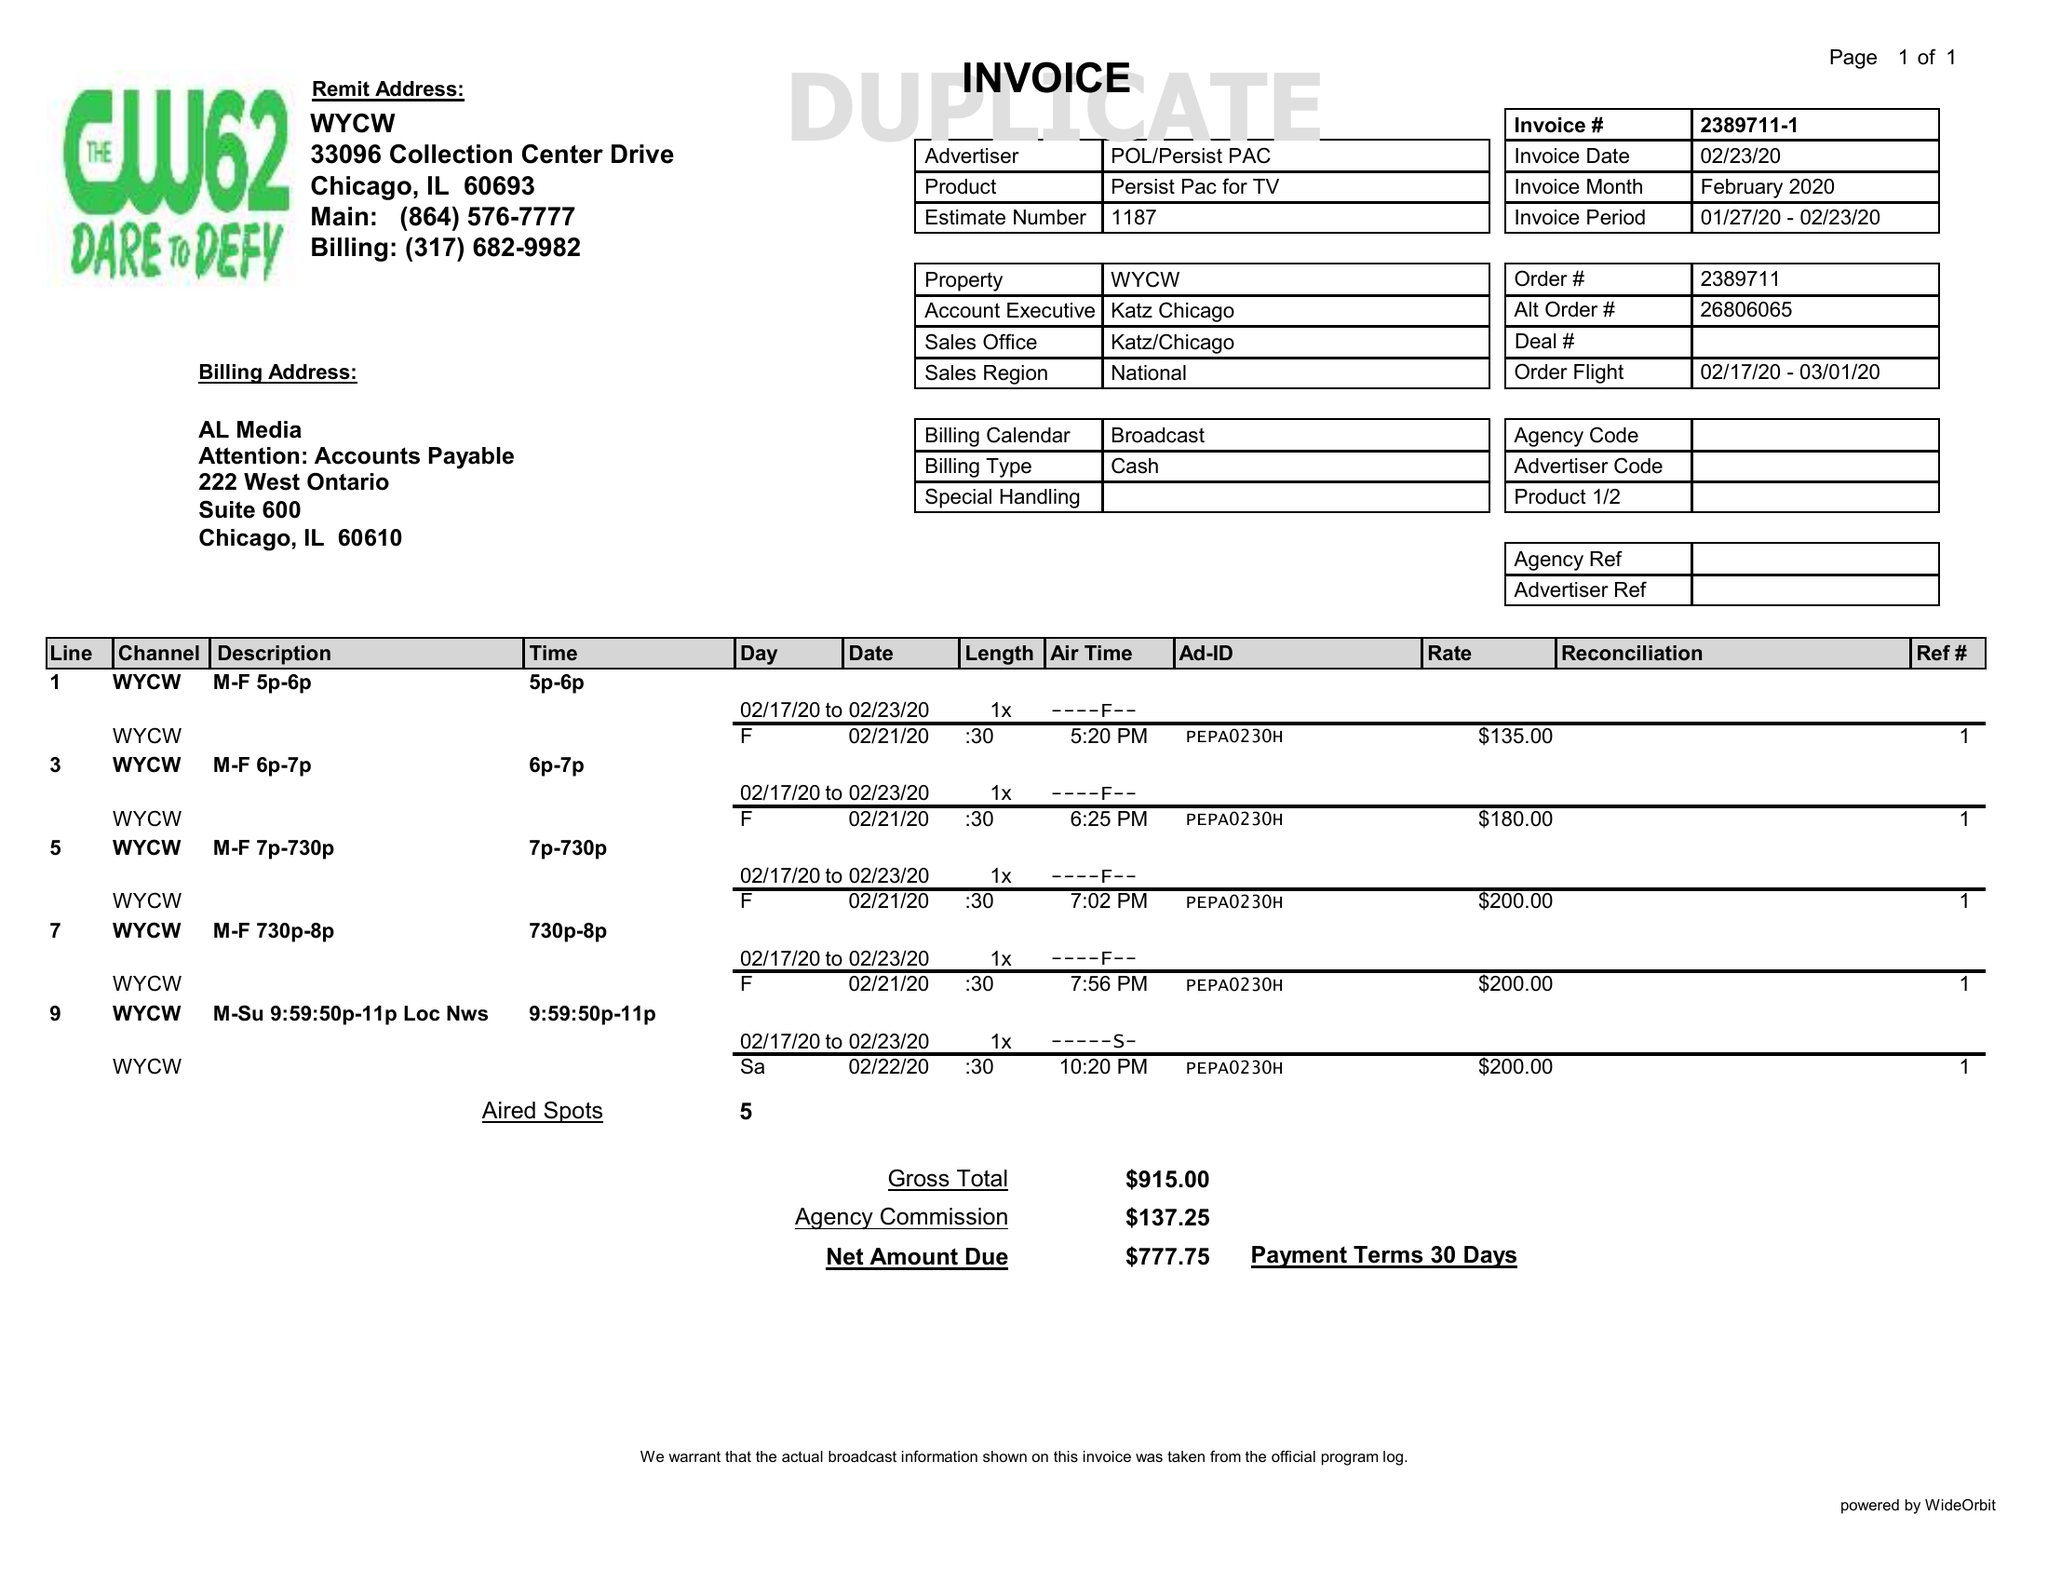What is the value for the contract_num?
Answer the question using a single word or phrase. 2389711 